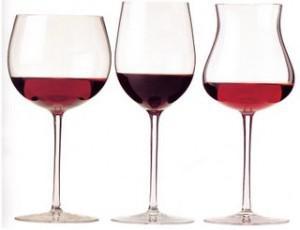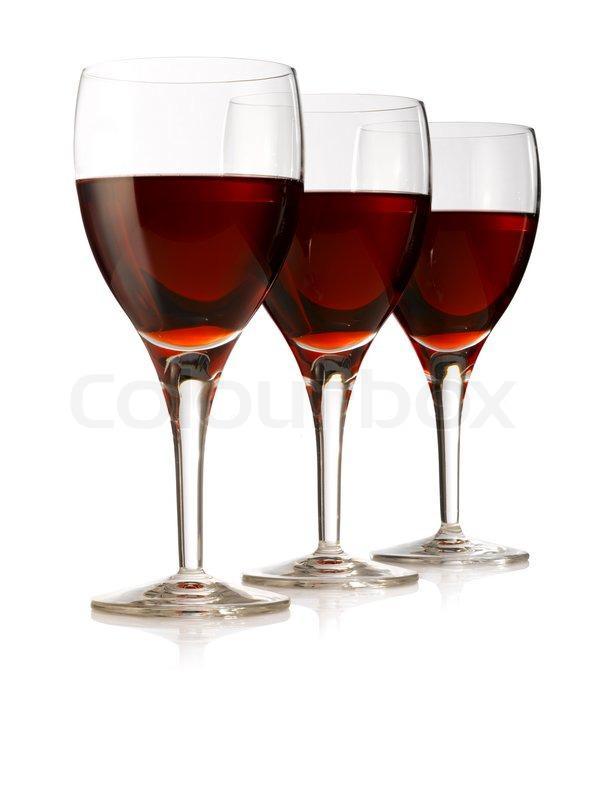The first image is the image on the left, the second image is the image on the right. Analyze the images presented: Is the assertion "An image includes a trio of stemmed glasses all containing red wine, with the middle glass in front of the other two." valid? Answer yes or no. No. 